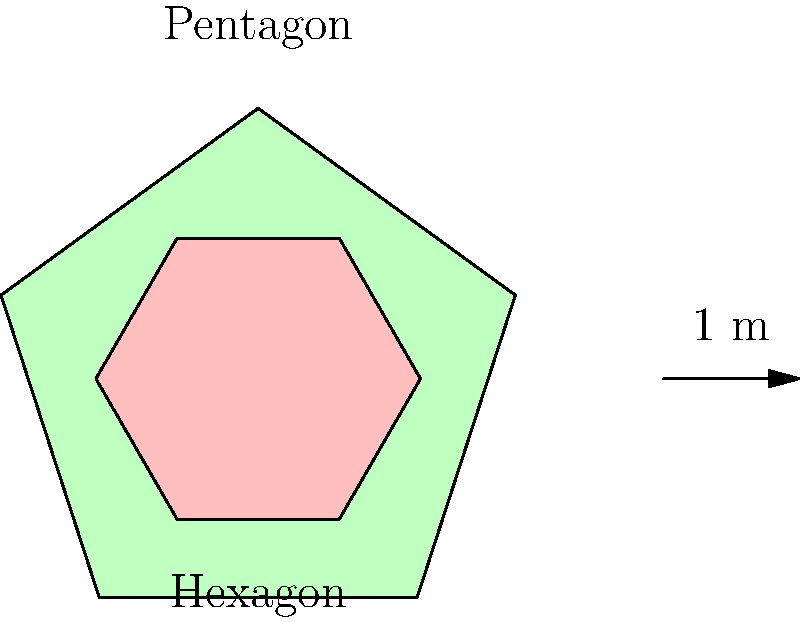A silk-screen printer is developing an eco-friendly dye coverage system. The image shows two fabric shapes: a pentagon and a hexagon. The arrow represents 1 meter. If the dye coverage is 0.15 liters per square meter, how much more dye (in milliliters) is needed to cover the pentagon compared to the hexagon? Let's approach this step-by-step:

1) First, we need to calculate the areas of both shapes.

2) For a regular pentagon with side length $s$:
   Area = $\frac{1}{4}\sqrt{25+10\sqrt{5}}s^2$

3) For a regular hexagon with side length $s$:
   Area = $\frac{3\sqrt{3}}{2}s^2$

4) From the scale, we can see that the pentagon's side length is about 1 meter.

5) The hexagon is scaled to 0.6 of the pentagon's size, so its side length is 0.6 meters.

6) Calculating areas:
   Pentagon: $\frac{1}{4}\sqrt{25+10\sqrt{5}} \approx 2.38$ sq meters
   Hexagon: $\frac{3\sqrt{3}}{2}(0.6)^2 \approx 0.94$ sq meters

7) Difference in area: $2.38 - 0.94 = 1.44$ sq meters

8) Dye needed: $1.44 \times 0.15 = 0.216$ liters

9) Converting to milliliters: $0.216 \times 1000 = 216$ ml

Therefore, 216 ml more dye is needed for the pentagon.
Answer: 216 ml 